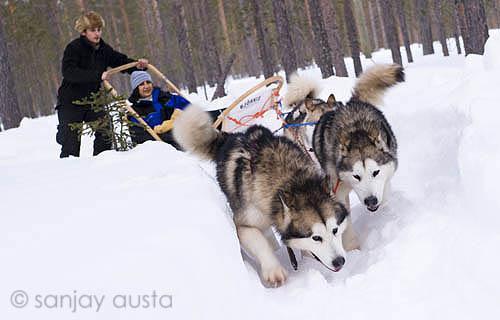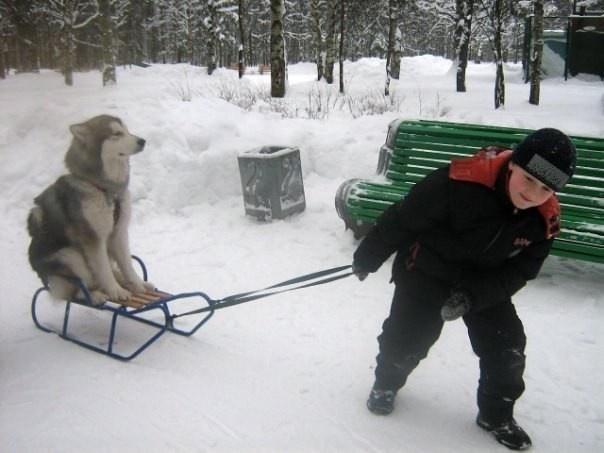The first image is the image on the left, the second image is the image on the right. Given the left and right images, does the statement "An image includes a child in a dark jacket leaning forward as he pulls a sled carrying one upright sitting husky on it across the snow." hold true? Answer yes or no. Yes. The first image is the image on the left, the second image is the image on the right. Analyze the images presented: Is the assertion "In the right image, there's at least one instance of a child pulling a dog on a sled." valid? Answer yes or no. Yes. 